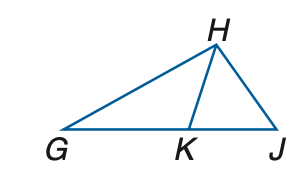Question: In the figure, G K \cong G H and H K \cong K J. If m \angle H G K = 42, find m \angle H J K.
Choices:
A. 34.5
B. 39.5
C. 42
D. 48
Answer with the letter. Answer: A Question: In the figure, G K \cong G H and H K \cong K J. If m \angle H G K = 28, find m \angle H J K.
Choices:
A. 38
B. 42
C. 46
D. 56
Answer with the letter. Answer: A 